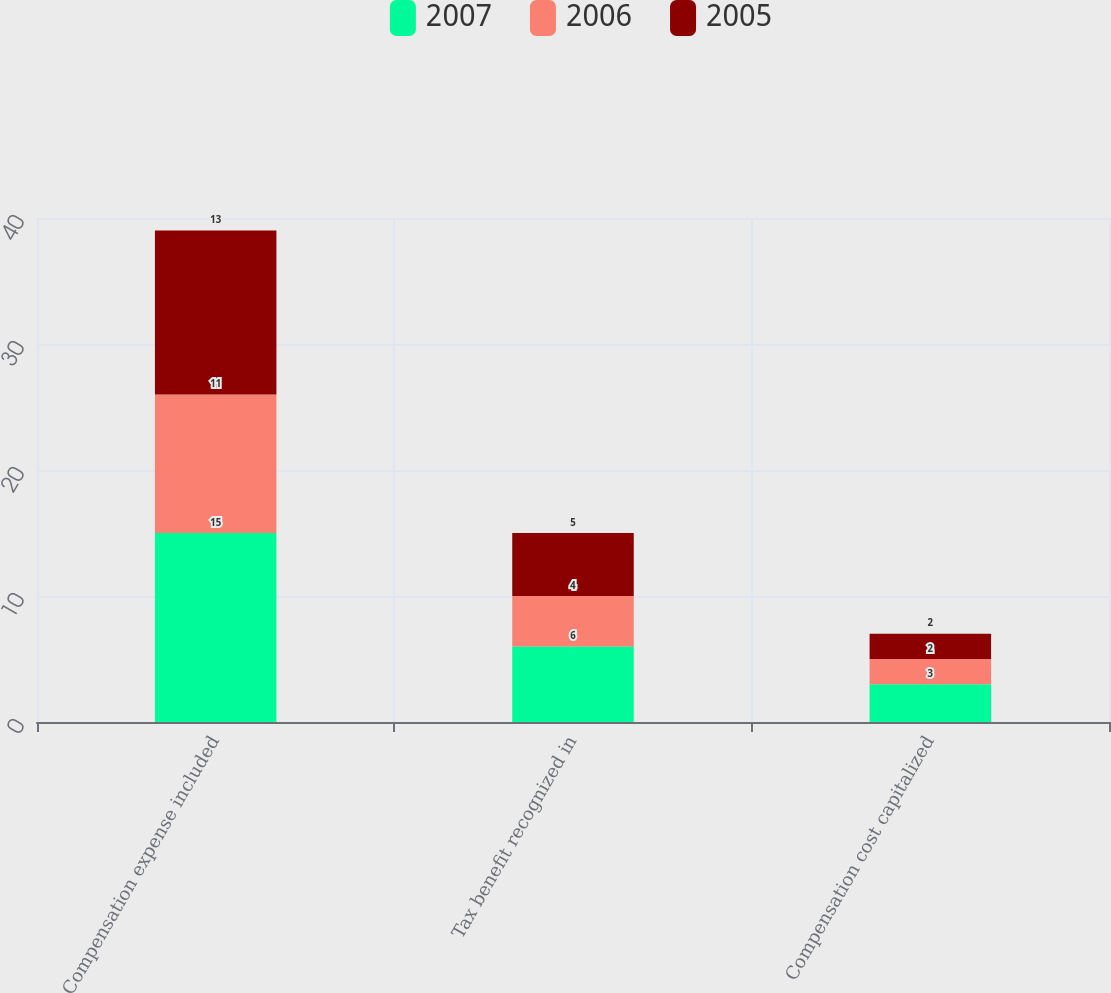<chart> <loc_0><loc_0><loc_500><loc_500><stacked_bar_chart><ecel><fcel>Compensation expense included<fcel>Tax benefit recognized in<fcel>Compensation cost capitalized<nl><fcel>2007<fcel>15<fcel>6<fcel>3<nl><fcel>2006<fcel>11<fcel>4<fcel>2<nl><fcel>2005<fcel>13<fcel>5<fcel>2<nl></chart> 